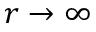<formula> <loc_0><loc_0><loc_500><loc_500>r \rightarrow \infty</formula> 